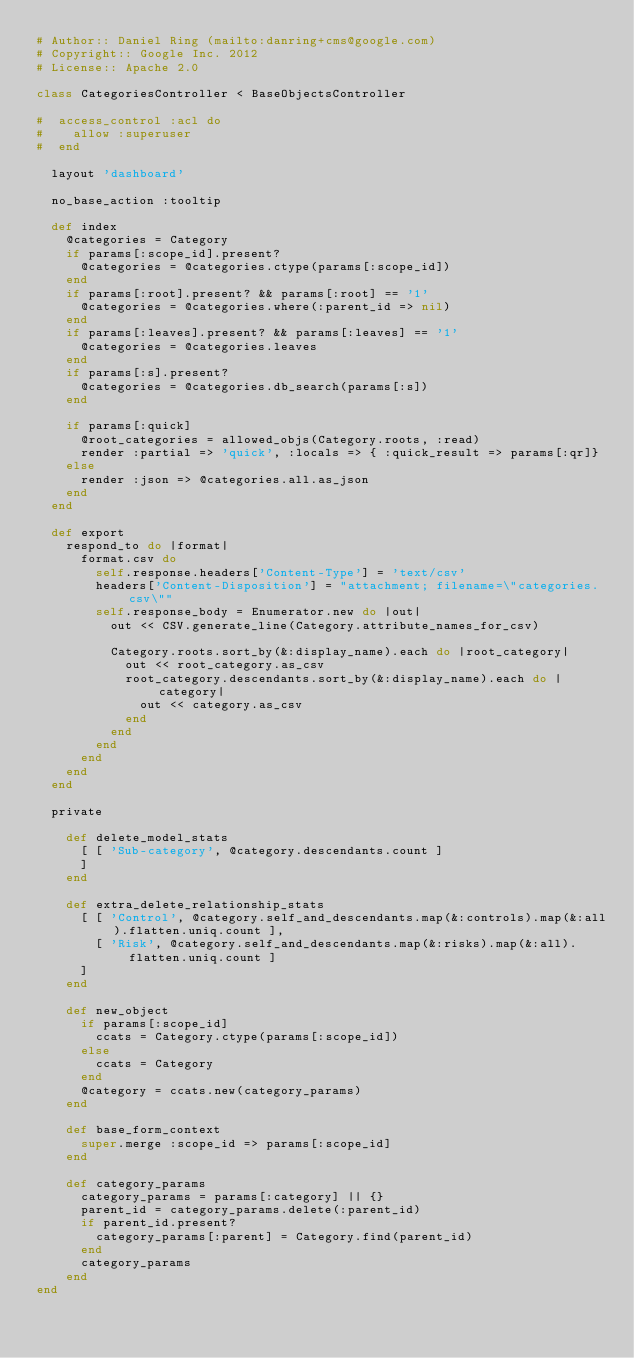Convert code to text. <code><loc_0><loc_0><loc_500><loc_500><_Ruby_># Author:: Daniel Ring (mailto:danring+cms@google.com)
# Copyright:: Google Inc. 2012
# License:: Apache 2.0

class CategoriesController < BaseObjectsController

#  access_control :acl do
#    allow :superuser
#  end

  layout 'dashboard'

  no_base_action :tooltip

  def index
    @categories = Category
    if params[:scope_id].present?
      @categories = @categories.ctype(params[:scope_id])
    end
    if params[:root].present? && params[:root] == '1'
      @categories = @categories.where(:parent_id => nil)
    end
    if params[:leaves].present? && params[:leaves] == '1'
      @categories = @categories.leaves
    end
    if params[:s].present?
      @categories = @categories.db_search(params[:s])
    end

    if params[:quick]
      @root_categories = allowed_objs(Category.roots, :read)
      render :partial => 'quick', :locals => { :quick_result => params[:qr]}
    else
      render :json => @categories.all.as_json
    end
  end

  def export
    respond_to do |format|
      format.csv do
        self.response.headers['Content-Type'] = 'text/csv'
        headers['Content-Disposition'] = "attachment; filename=\"categories.csv\""
        self.response_body = Enumerator.new do |out|
          out << CSV.generate_line(Category.attribute_names_for_csv)

          Category.roots.sort_by(&:display_name).each do |root_category|
            out << root_category.as_csv
            root_category.descendants.sort_by(&:display_name).each do |category|
              out << category.as_csv
            end
          end
        end
      end
    end
  end

  private

    def delete_model_stats
      [ [ 'Sub-category', @category.descendants.count ]
      ]
    end

    def extra_delete_relationship_stats
      [ [ 'Control', @category.self_and_descendants.map(&:controls).map(&:all).flatten.uniq.count ],
        [ 'Risk', @category.self_and_descendants.map(&:risks).map(&:all).flatten.uniq.count ]
      ]
    end

    def new_object
      if params[:scope_id]
        ccats = Category.ctype(params[:scope_id])
      else
        ccats = Category
      end
      @category = ccats.new(category_params)
    end

    def base_form_context
      super.merge :scope_id => params[:scope_id]
    end

    def category_params
      category_params = params[:category] || {}
      parent_id = category_params.delete(:parent_id)
      if parent_id.present?
        category_params[:parent] = Category.find(parent_id)
      end
      category_params
    end
end
</code> 